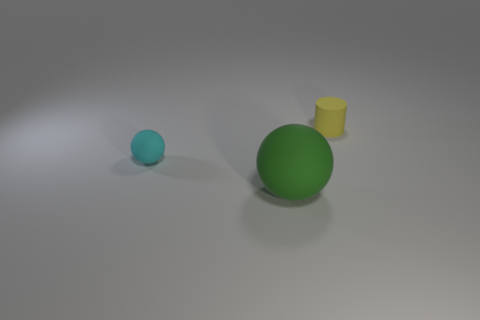Add 3 tiny yellow rubber things. How many objects exist? 6 Subtract all balls. How many objects are left? 1 Subtract 0 blue spheres. How many objects are left? 3 Subtract all tiny rubber spheres. Subtract all large things. How many objects are left? 1 Add 2 small yellow rubber cylinders. How many small yellow rubber cylinders are left? 3 Add 1 cyan objects. How many cyan objects exist? 2 